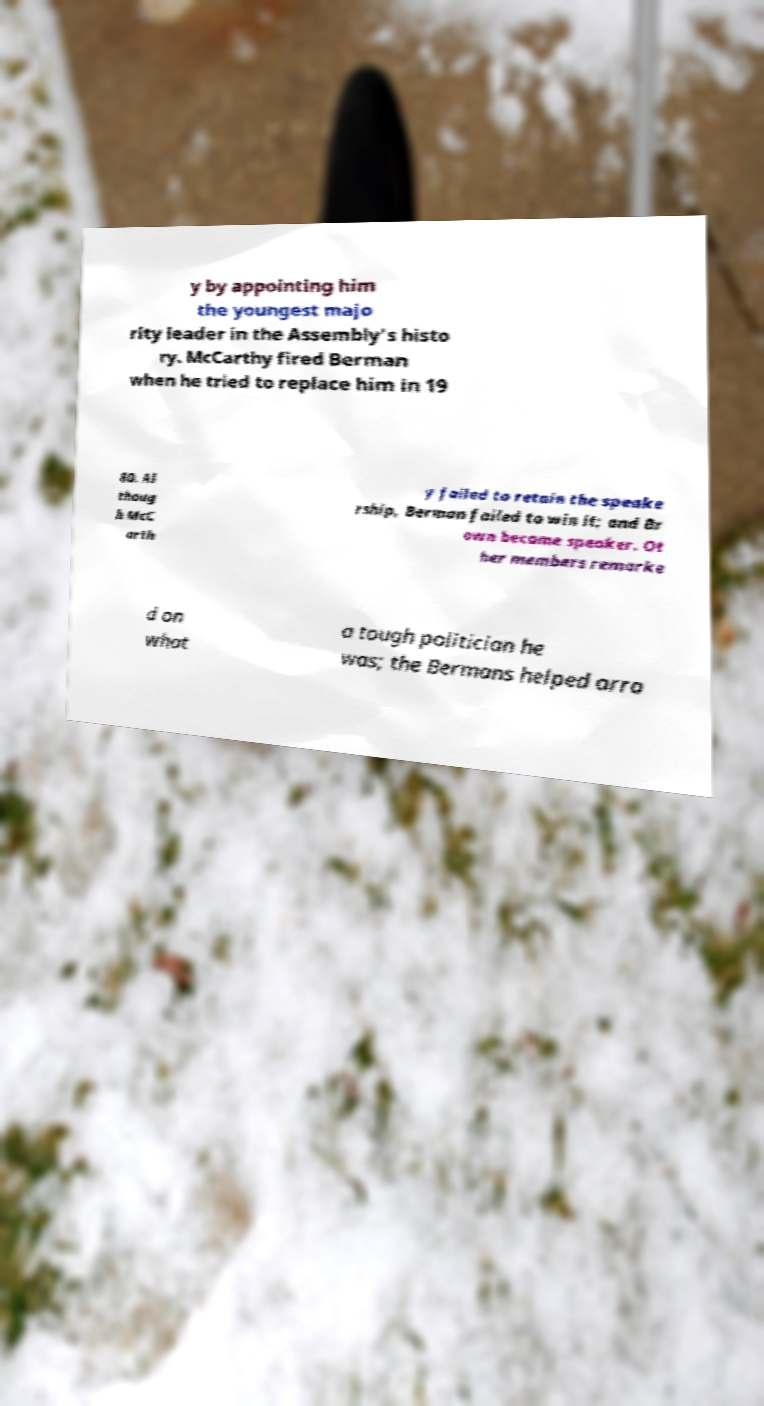I need the written content from this picture converted into text. Can you do that? y by appointing him the youngest majo rity leader in the Assembly's histo ry. McCarthy fired Berman when he tried to replace him in 19 80. Al thoug h McC arth y failed to retain the speake rship, Berman failed to win it; and Br own became speaker. Ot her members remarke d on what a tough politician he was; the Bermans helped arra 